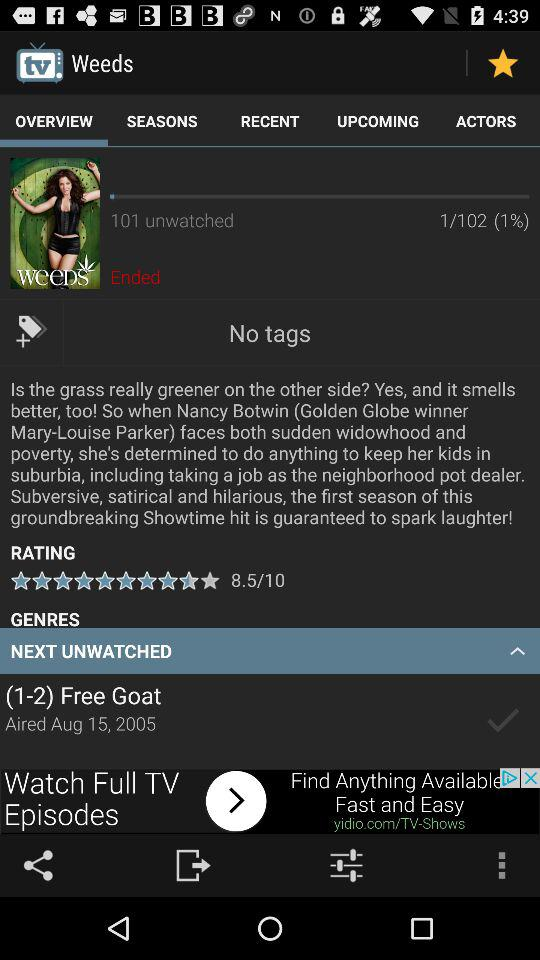Which tab is selected? The selected tab is "OVERVIEW". 